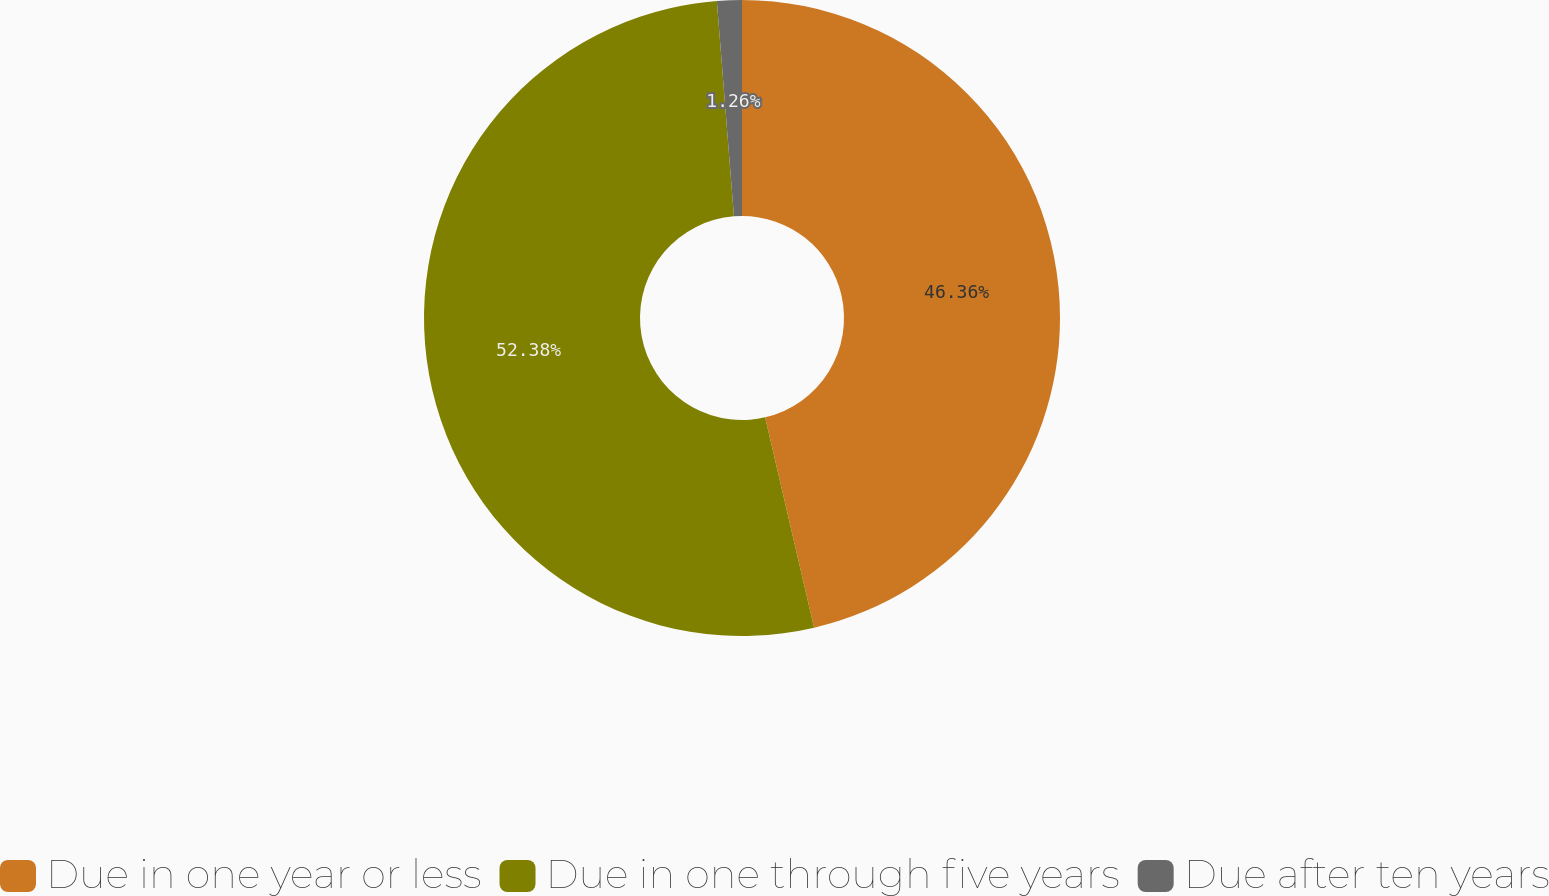Convert chart to OTSL. <chart><loc_0><loc_0><loc_500><loc_500><pie_chart><fcel>Due in one year or less<fcel>Due in one through five years<fcel>Due after ten years<nl><fcel>46.36%<fcel>52.38%<fcel>1.26%<nl></chart> 